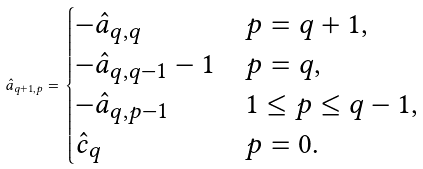Convert formula to latex. <formula><loc_0><loc_0><loc_500><loc_500>\hat { a } _ { q + 1 , p } = \begin{cases} - \hat { a } _ { q , q } & p = q + 1 , \\ - \hat { a } _ { q , q - 1 } - 1 & p = q , \\ - \hat { a } _ { q , p - 1 } & 1 \leq p \leq q - 1 , \\ \hat { c } _ { q } & p = 0 . \end{cases}</formula> 